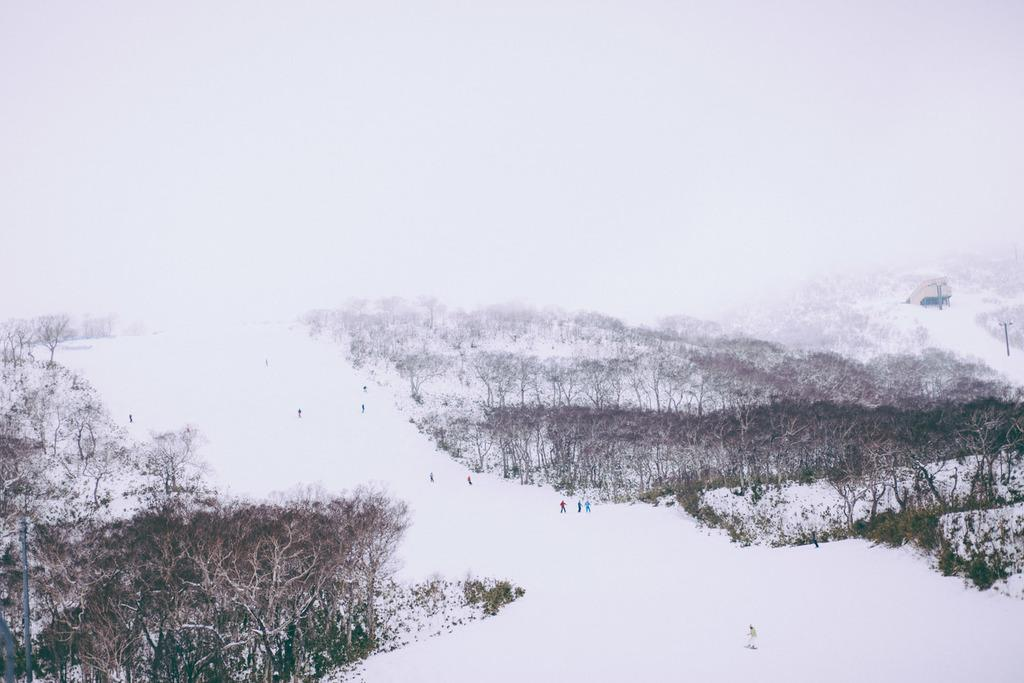What can be seen in the background of the image? The sky is visible in the image. What are the persons in the image doing? The persons are on the snow in the image. What structure is present in the image? There is an electric pole in the image. What type of vegetation is present in the image? Trees are present in the image. What type of thread is being used to create the air in the image? There is no thread present in the image, and the air is a natural element that does not require any creation. 